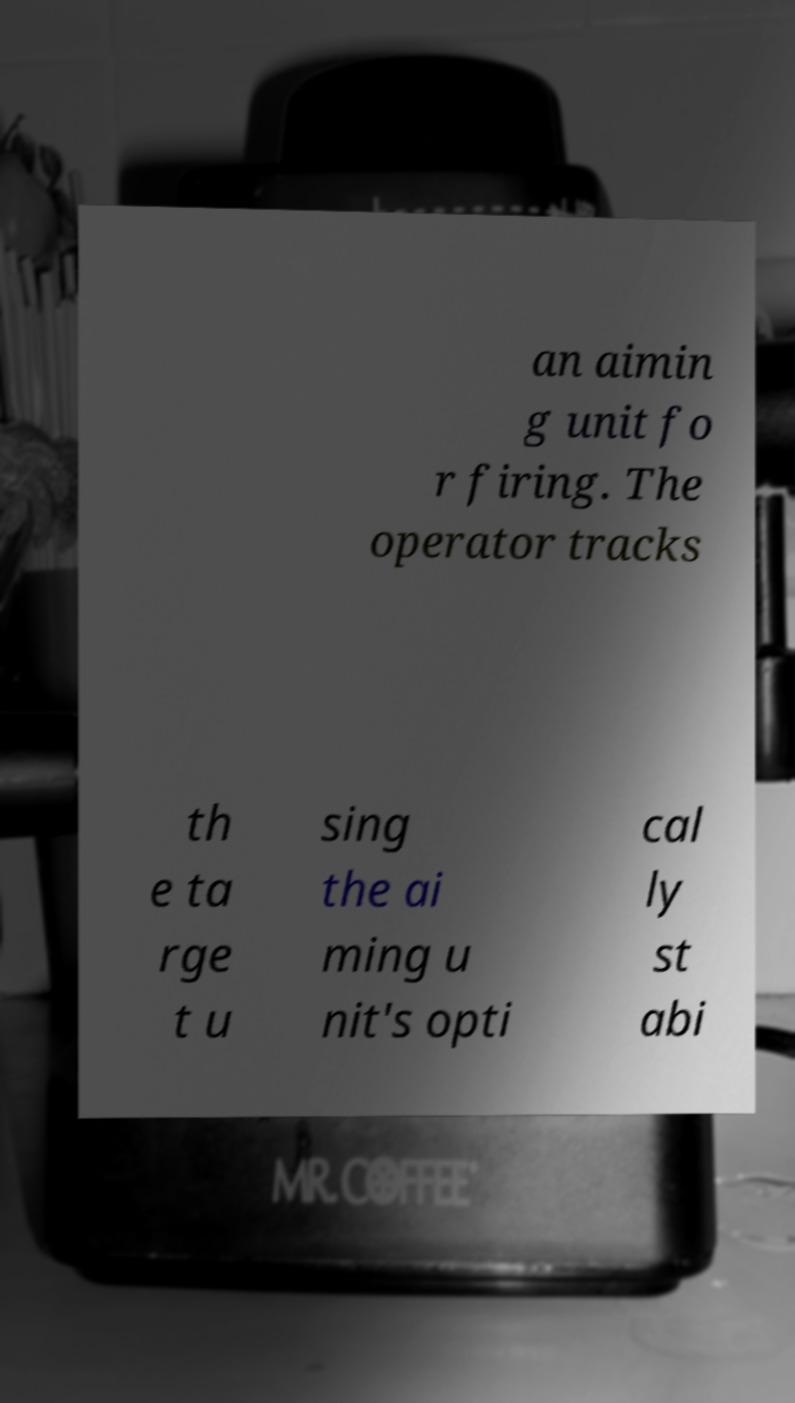Please read and relay the text visible in this image. What does it say? an aimin g unit fo r firing. The operator tracks th e ta rge t u sing the ai ming u nit's opti cal ly st abi 